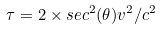Convert formula to latex. <formula><loc_0><loc_0><loc_500><loc_500>\tau = 2 \times s e c ^ { 2 } ( \theta ) v ^ { 2 } / c ^ { 2 }</formula> 